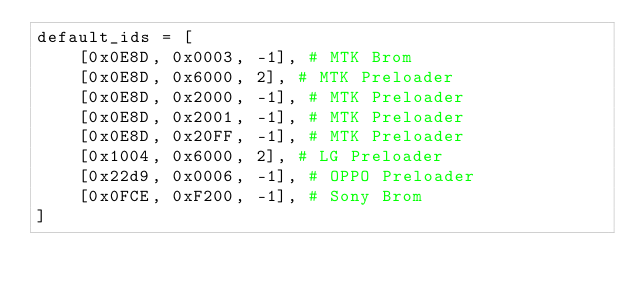<code> <loc_0><loc_0><loc_500><loc_500><_Python_>default_ids = [
    [0x0E8D, 0x0003, -1], # MTK Brom
    [0x0E8D, 0x6000, 2], # MTK Preloader
    [0x0E8D, 0x2000, -1], # MTK Preloader
    [0x0E8D, 0x2001, -1], # MTK Preloader
    [0x0E8D, 0x20FF, -1], # MTK Preloader
    [0x1004, 0x6000, 2], # LG Preloader
    [0x22d9, 0x0006, -1], # OPPO Preloader
    [0x0FCE, 0xF200, -1], # Sony Brom
]
</code> 